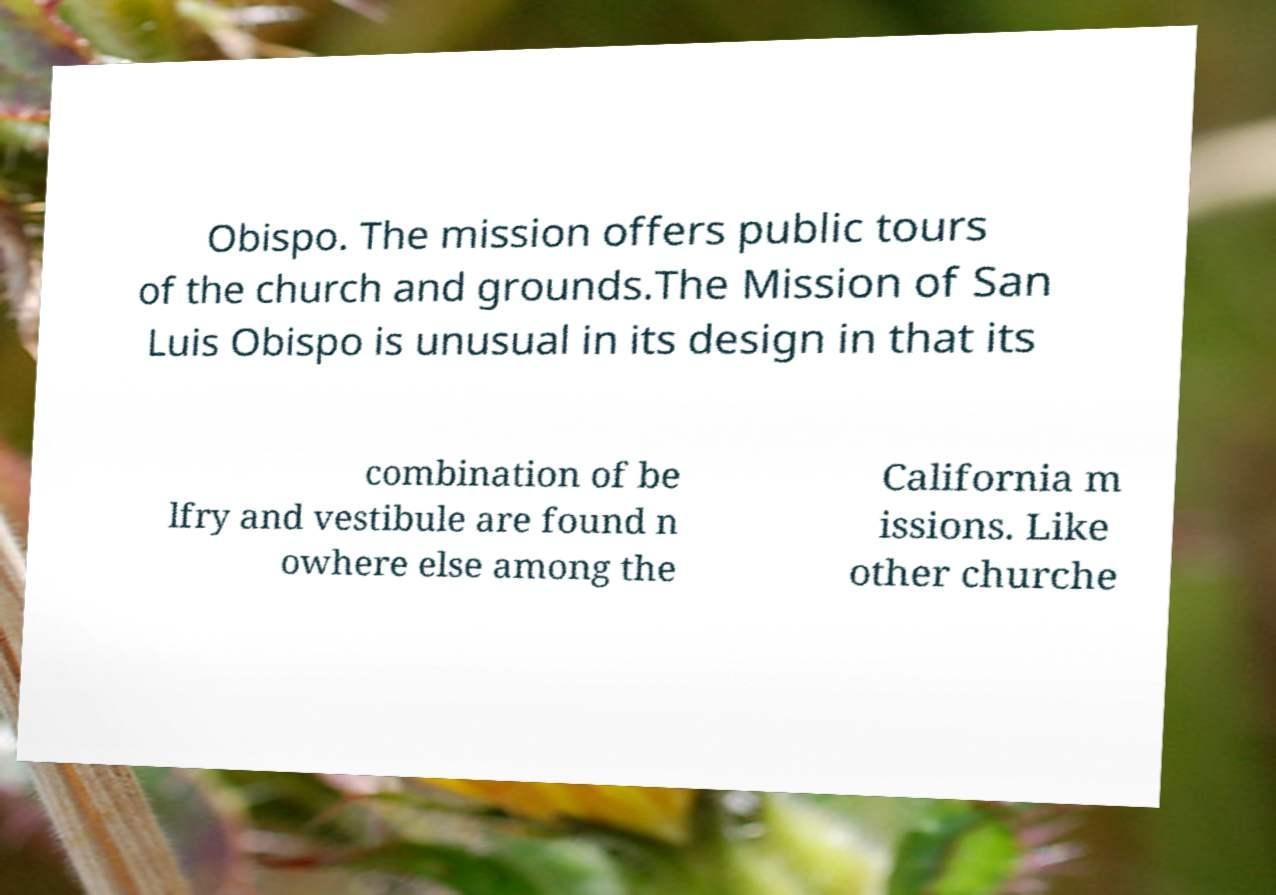I need the written content from this picture converted into text. Can you do that? Obispo. The mission offers public tours of the church and grounds.The Mission of San Luis Obispo is unusual in its design in that its combination of be lfry and vestibule are found n owhere else among the California m issions. Like other churche 